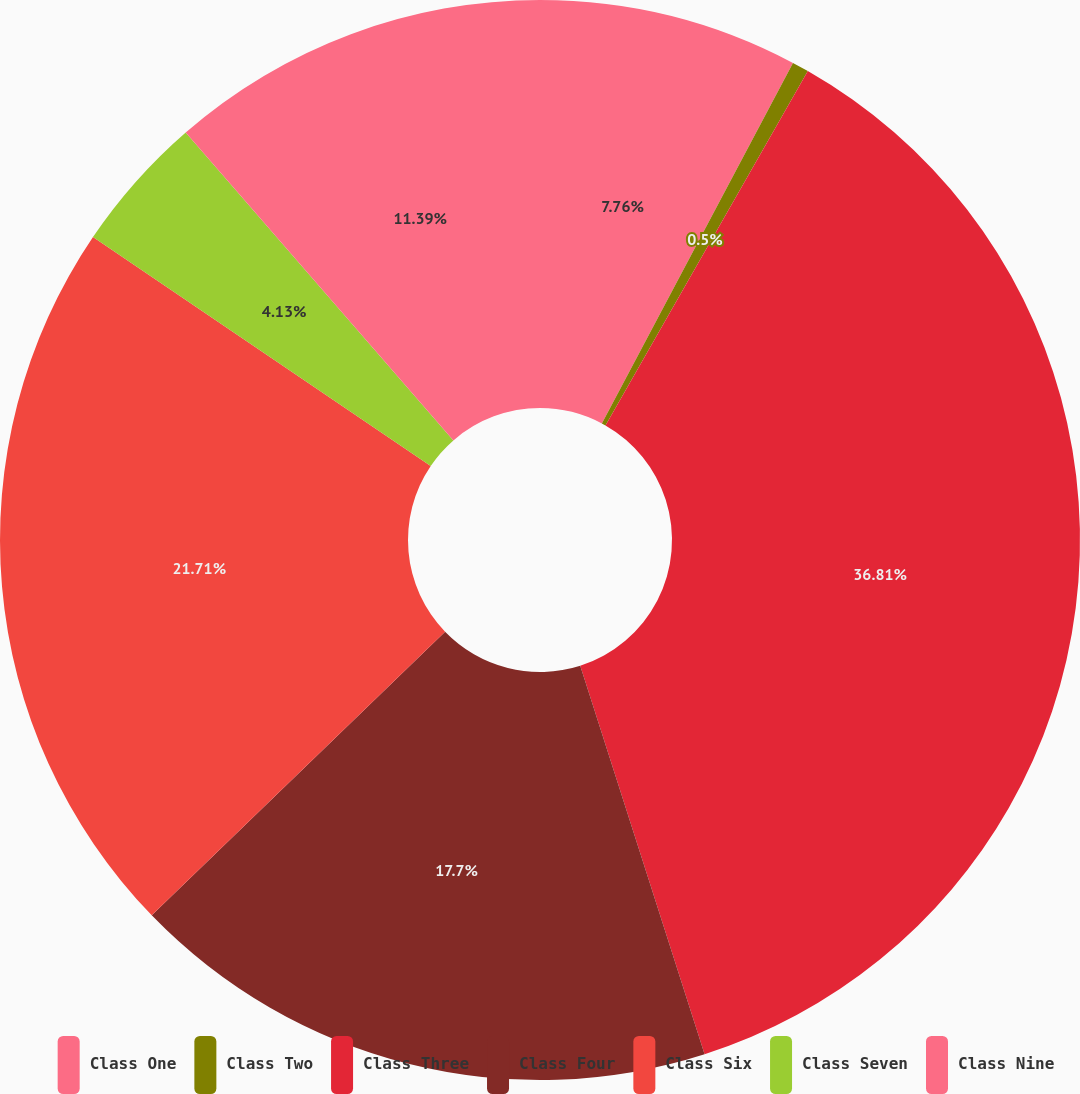<chart> <loc_0><loc_0><loc_500><loc_500><pie_chart><fcel>Class One<fcel>Class Two<fcel>Class Three<fcel>Class Four<fcel>Class Six<fcel>Class Seven<fcel>Class Nine<nl><fcel>7.76%<fcel>0.5%<fcel>36.81%<fcel>17.7%<fcel>21.71%<fcel>4.13%<fcel>11.39%<nl></chart> 